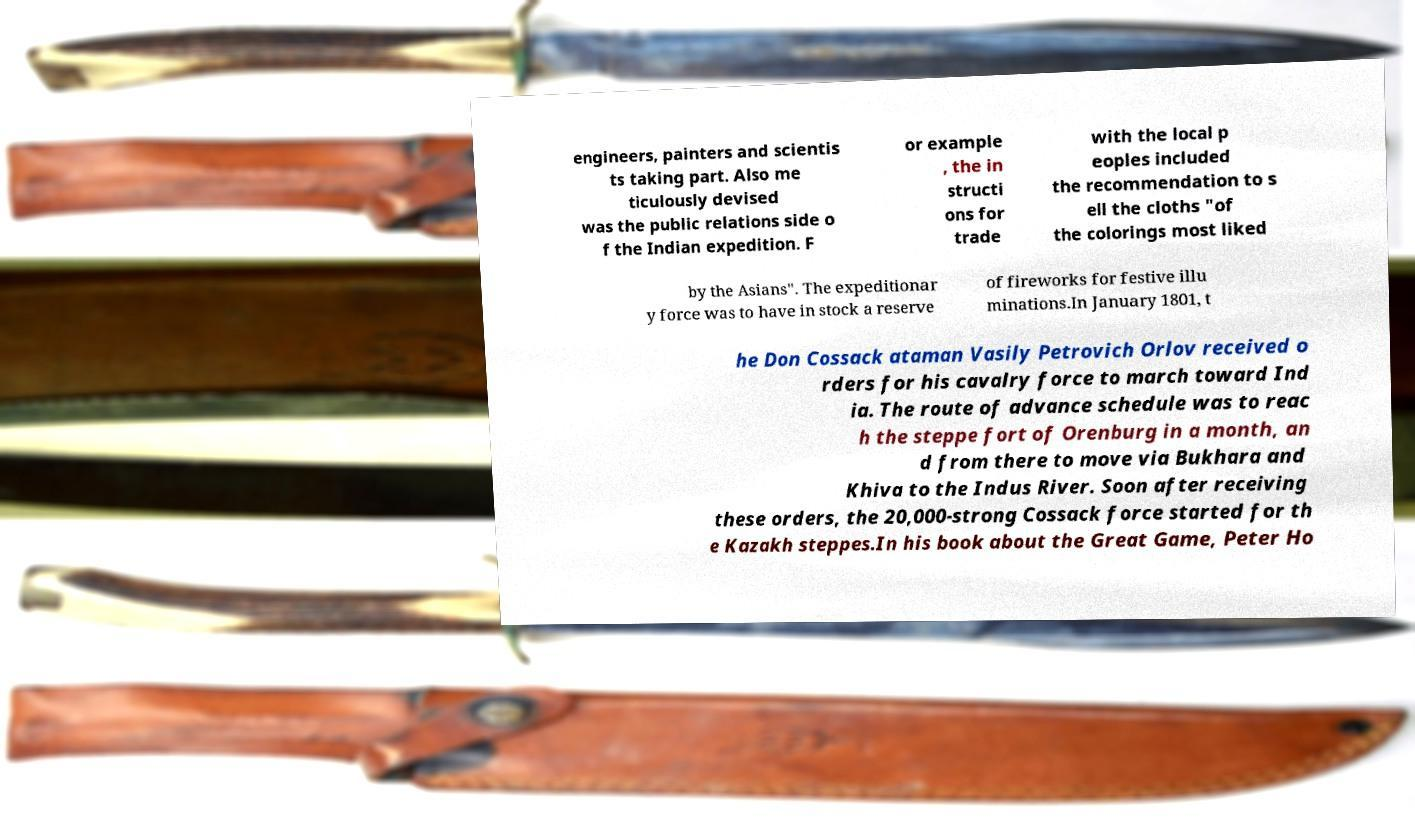Please identify and transcribe the text found in this image. engineers, painters and scientis ts taking part. Also me ticulously devised was the public relations side o f the Indian expedition. F or example , the in structi ons for trade with the local p eoples included the recommendation to s ell the cloths "of the colorings most liked by the Asians". The expeditionar y force was to have in stock a reserve of fireworks for festive illu minations.In January 1801, t he Don Cossack ataman Vasily Petrovich Orlov received o rders for his cavalry force to march toward Ind ia. The route of advance schedule was to reac h the steppe fort of Orenburg in a month, an d from there to move via Bukhara and Khiva to the Indus River. Soon after receiving these orders, the 20,000-strong Cossack force started for th e Kazakh steppes.In his book about the Great Game, Peter Ho 